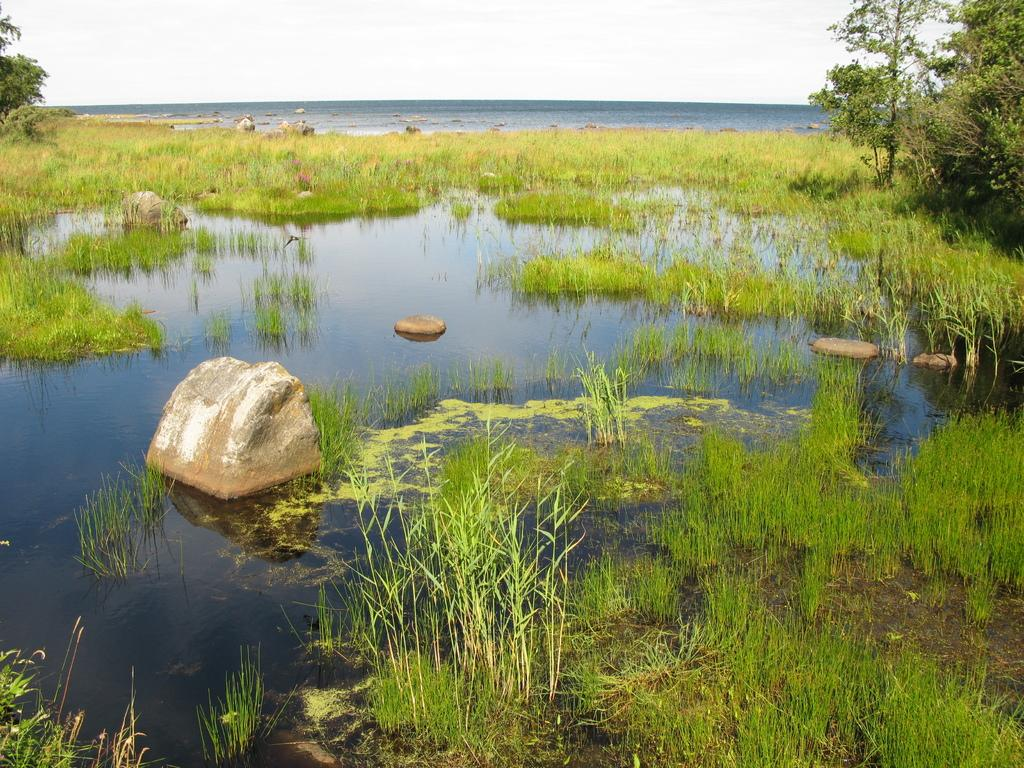What type of vegetation is present in the image? There is grass in the image. What can be seen in the water in the image? There are rocks in the water in the image. What type of natural structures are visible in the image? There are trees visible in the image. What type of stew is being prepared in the image? There is no stew present in the image; it features grass, rocks in water, and trees. What type of territory is depicted in the image? The image does not depict a specific territory; it shows natural elements such as grass, rocks in water, and trees. 